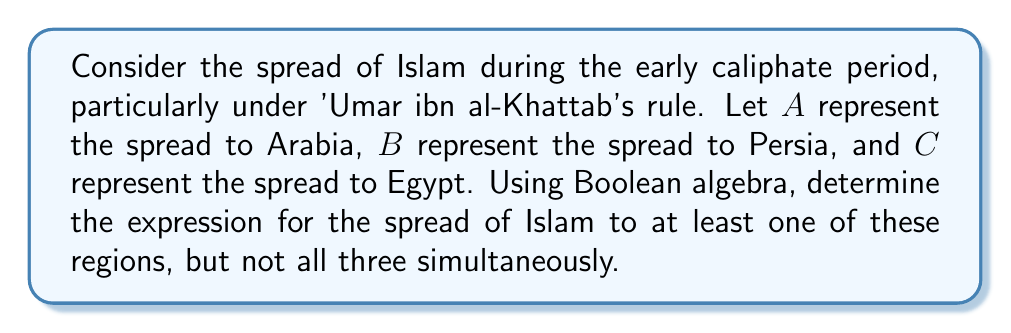Show me your answer to this math problem. To solve this problem using Boolean algebra, we'll follow these steps:

1) First, let's define our Boolean variables:
   A: Spread to Arabia
   B: Spread to Persia
   C: Spread to Egypt

2) We want to express "at least one, but not all three". This can be broken down into two parts:
   - At least one: $(A + B + C)$
   - Not all three: $\overline{(A \cdot B \cdot C)}$

3) Combining these using the AND operation:
   $(A + B + C) \cdot \overline{(A \cdot B \cdot C)}$

4) We can simplify this using Boolean algebra laws:
   $(A + B + C) \cdot (\overline{A} + \overline{B} + \overline{C})$

5) Expanding this expression:
   $(A \cdot \overline{A}) + (A \cdot \overline{B}) + (A \cdot \overline{C}) + (B \cdot \overline{A}) + (B \cdot \overline{B}) + (B \cdot \overline{C}) + (C \cdot \overline{A}) + (C \cdot \overline{B}) + (C \cdot \overline{C})$

6) Simplify using Boolean algebra laws:
   - $A \cdot \overline{A} = 0$
   - $B \cdot \overline{B} = 0$
   - $C \cdot \overline{C} = 0$

7) The final simplified expression is:
   $(A \cdot \overline{B}) + (A \cdot \overline{C}) + (B \cdot \overline{A}) + (B \cdot \overline{C}) + (C \cdot \overline{A}) + (C \cdot \overline{B})$

This expression represents the spread of Islam to at least one region, but not all three, during 'Umar ibn al-Khattab's caliphate.
Answer: $(A \cdot \overline{B}) + (A \cdot \overline{C}) + (B \cdot \overline{A}) + (B \cdot \overline{C}) + (C \cdot \overline{A}) + (C \cdot \overline{B})$ 